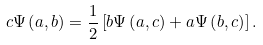Convert formula to latex. <formula><loc_0><loc_0><loc_500><loc_500>c \Psi \left ( a , b \right ) = \frac { 1 } { 2 } \left [ b \Psi \left ( a , c \right ) + a \Psi \left ( b , c \right ) \right ] .</formula> 